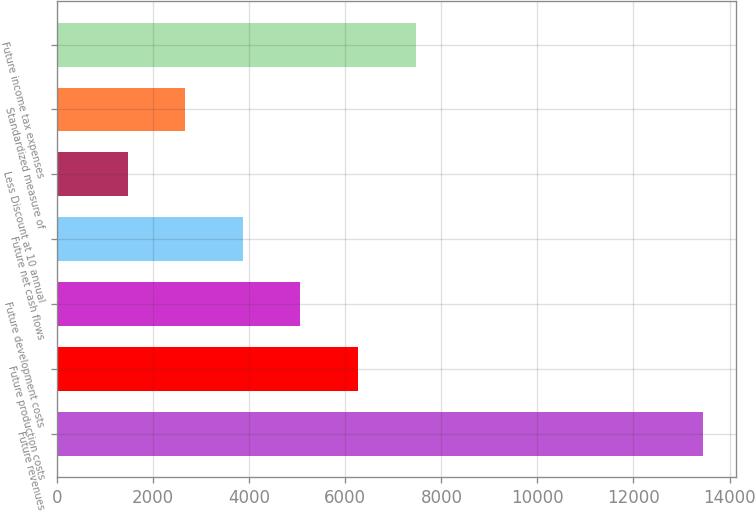Convert chart. <chart><loc_0><loc_0><loc_500><loc_500><bar_chart><fcel>Future revenues<fcel>Future production costs<fcel>Future development costs<fcel>Future net cash flows<fcel>Less Discount at 10 annual<fcel>Standardized measure of<fcel>Future income tax expenses<nl><fcel>13456<fcel>6263.8<fcel>5065.1<fcel>3866.4<fcel>1469<fcel>2667.7<fcel>7462.5<nl></chart> 